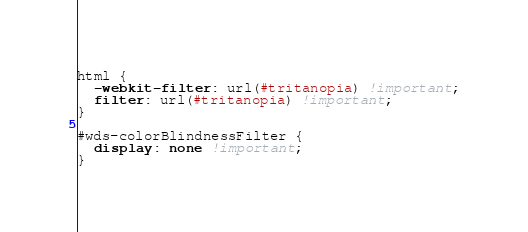<code> <loc_0><loc_0><loc_500><loc_500><_CSS_>
html {
  -webkit-filter: url(#tritanopia) !important;
  filter: url(#tritanopia) !important;
}

#wds-colorBlindnessFilter {
  display: none !important; 
}</code> 